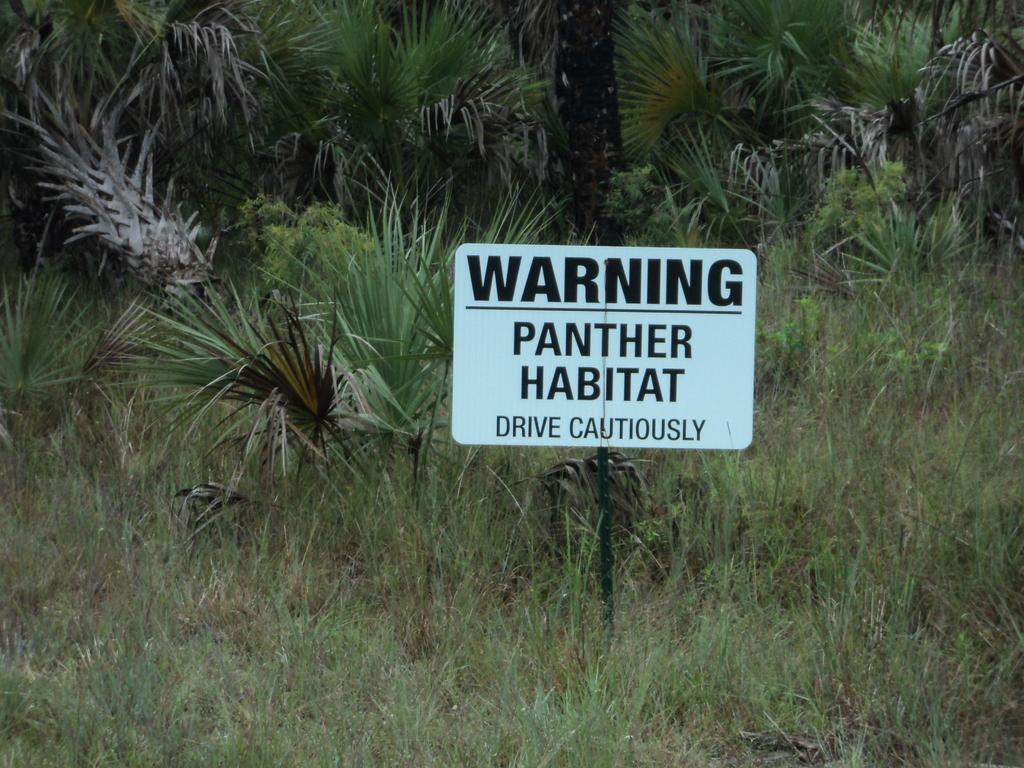What is the main object in the center of the image? There is a warning board in the center of the image. What can be seen in the surroundings of the image? There are plants around the area of the image. What decision is being made by the goldfish in the image? There are no goldfish present in the image, so no decision can be made by them. 